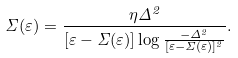Convert formula to latex. <formula><loc_0><loc_0><loc_500><loc_500>\Sigma ( \varepsilon ) = \frac { \eta \Delta ^ { 2 } } { \left [ \varepsilon - \Sigma ( \varepsilon ) \right ] \log \frac { - \Delta ^ { 2 } } { [ \varepsilon - \Sigma ( \varepsilon ) ] ^ { 2 } } } .</formula> 